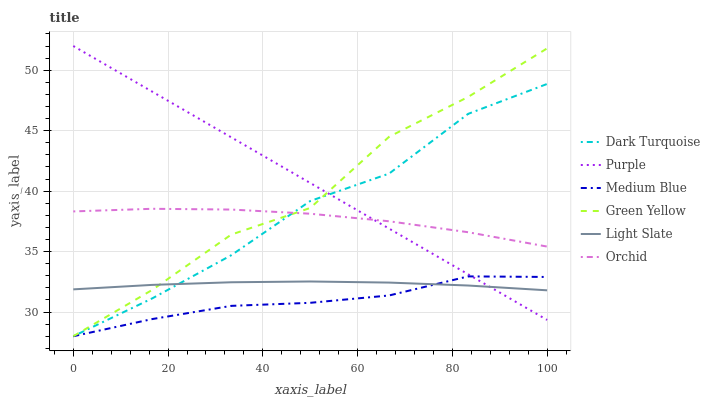Does Medium Blue have the minimum area under the curve?
Answer yes or no. Yes. Does Purple have the maximum area under the curve?
Answer yes or no. Yes. Does Dark Turquoise have the minimum area under the curve?
Answer yes or no. No. Does Dark Turquoise have the maximum area under the curve?
Answer yes or no. No. Is Purple the smoothest?
Answer yes or no. Yes. Is Green Yellow the roughest?
Answer yes or no. Yes. Is Dark Turquoise the smoothest?
Answer yes or no. No. Is Dark Turquoise the roughest?
Answer yes or no. No. Does Light Slate have the lowest value?
Answer yes or no. No. Does Purple have the highest value?
Answer yes or no. Yes. Does Dark Turquoise have the highest value?
Answer yes or no. No. Is Medium Blue less than Orchid?
Answer yes or no. Yes. Is Orchid greater than Medium Blue?
Answer yes or no. Yes. Does Dark Turquoise intersect Orchid?
Answer yes or no. Yes. Is Dark Turquoise less than Orchid?
Answer yes or no. No. Is Dark Turquoise greater than Orchid?
Answer yes or no. No. Does Medium Blue intersect Orchid?
Answer yes or no. No. 